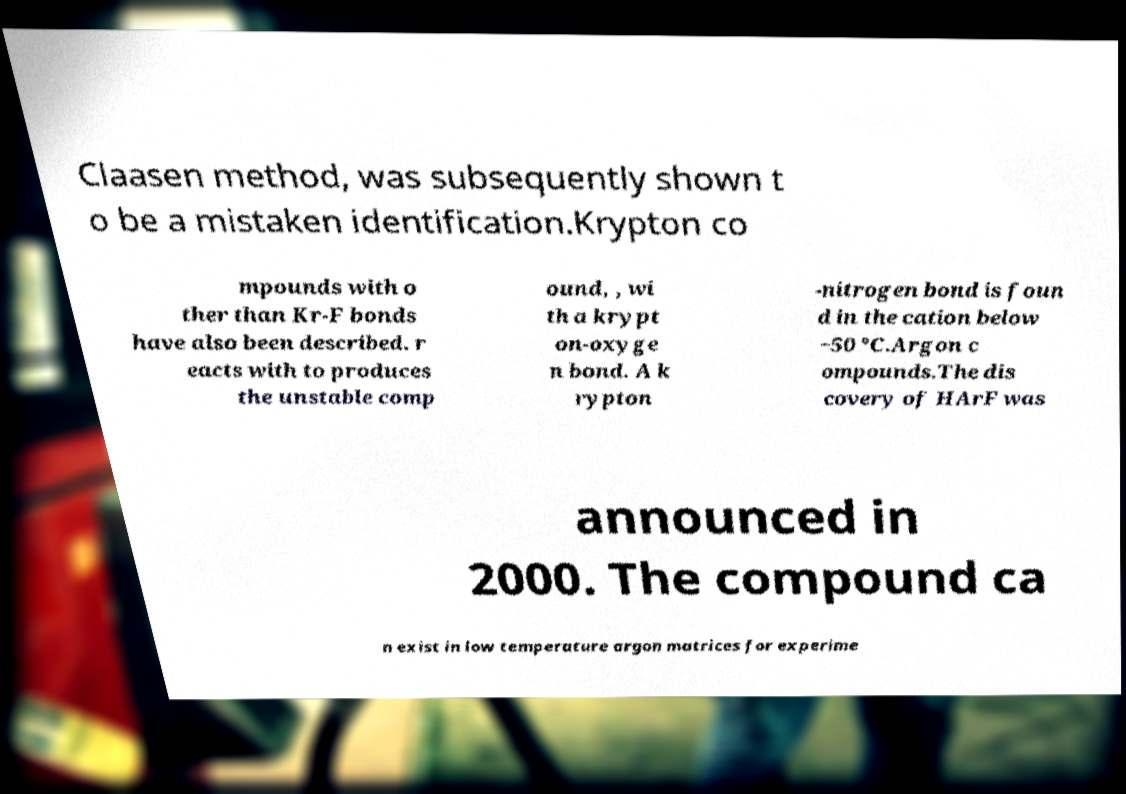There's text embedded in this image that I need extracted. Can you transcribe it verbatim? Claasen method, was subsequently shown t o be a mistaken identification.Krypton co mpounds with o ther than Kr-F bonds have also been described. r eacts with to produces the unstable comp ound, , wi th a krypt on-oxyge n bond. A k rypton -nitrogen bond is foun d in the cation below −50 °C.Argon c ompounds.The dis covery of HArF was announced in 2000. The compound ca n exist in low temperature argon matrices for experime 